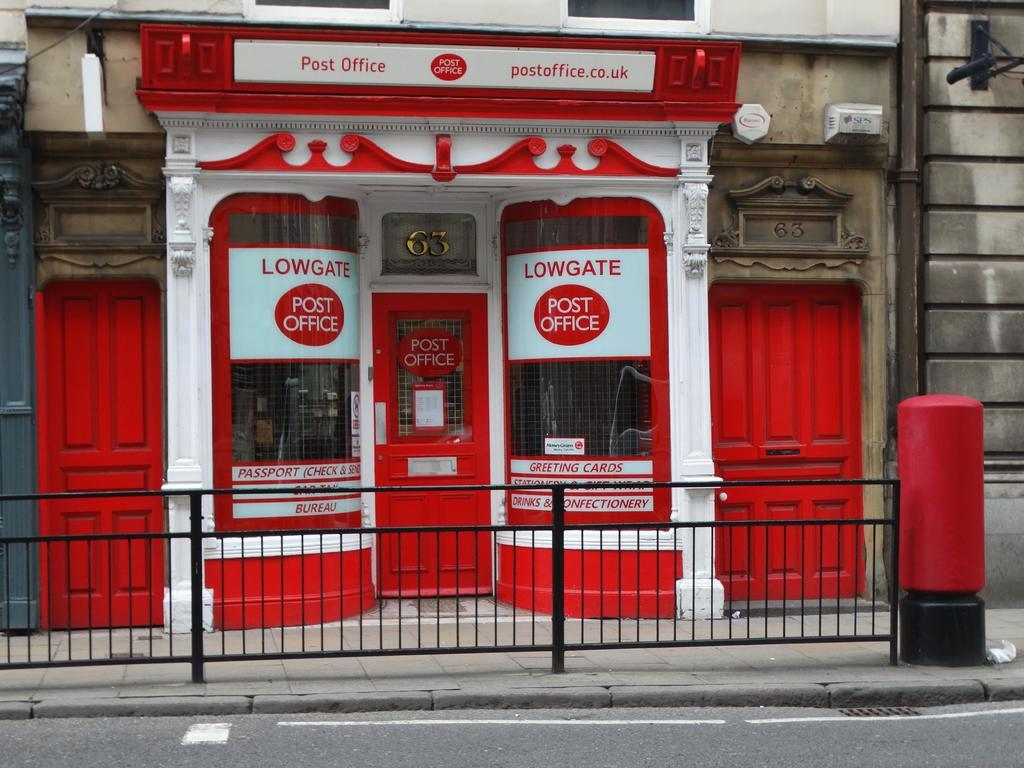What object is the main focus of the image? There is a post box in the image. What can be seen in the background of the image? There are two red doors and a building with a cream color in the background of the image. What architectural feature is visible in the image? The railing is visible in the image. What type of ornament is hanging from the post box in the image? There is no ornament hanging from the post box in the image. What is the weight of the spring visible in the image? There is no spring present in the image. 